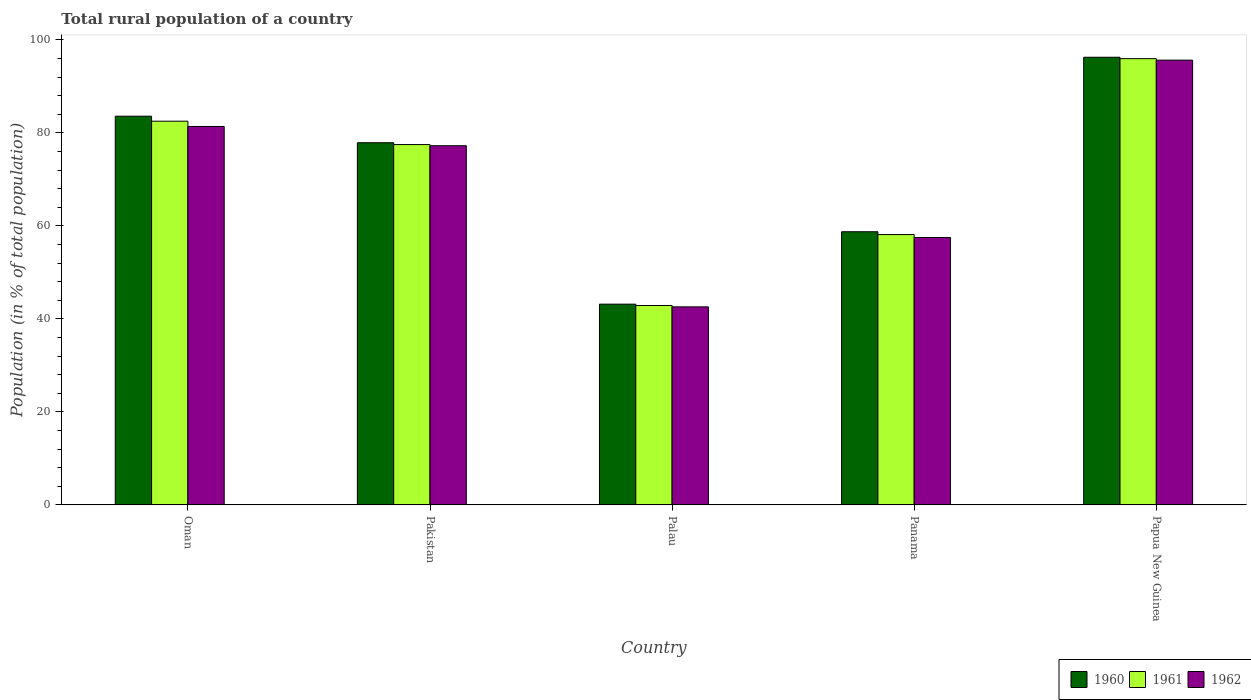How many different coloured bars are there?
Provide a succinct answer. 3. How many groups of bars are there?
Provide a short and direct response. 5. How many bars are there on the 2nd tick from the right?
Keep it short and to the point. 3. What is the label of the 3rd group of bars from the left?
Make the answer very short. Palau. In how many cases, is the number of bars for a given country not equal to the number of legend labels?
Your answer should be very brief. 0. What is the rural population in 1961 in Pakistan?
Make the answer very short. 77.5. Across all countries, what is the maximum rural population in 1961?
Provide a short and direct response. 95.98. Across all countries, what is the minimum rural population in 1962?
Your response must be concise. 42.59. In which country was the rural population in 1962 maximum?
Your response must be concise. Papua New Guinea. In which country was the rural population in 1962 minimum?
Make the answer very short. Palau. What is the total rural population in 1961 in the graph?
Your answer should be very brief. 357.03. What is the difference between the rural population in 1961 in Oman and that in Panama?
Provide a short and direct response. 24.38. What is the difference between the rural population in 1960 in Pakistan and the rural population in 1962 in Panama?
Make the answer very short. 20.39. What is the average rural population in 1961 per country?
Keep it short and to the point. 71.41. What is the difference between the rural population of/in 1960 and rural population of/in 1961 in Palau?
Ensure brevity in your answer.  0.29. In how many countries, is the rural population in 1962 greater than 80 %?
Offer a very short reply. 2. What is the ratio of the rural population in 1960 in Panama to that in Papua New Guinea?
Keep it short and to the point. 0.61. Is the difference between the rural population in 1960 in Pakistan and Palau greater than the difference between the rural population in 1961 in Pakistan and Palau?
Provide a succinct answer. Yes. What is the difference between the highest and the second highest rural population in 1960?
Your response must be concise. 12.68. What is the difference between the highest and the lowest rural population in 1962?
Give a very brief answer. 53.06. In how many countries, is the rural population in 1961 greater than the average rural population in 1961 taken over all countries?
Your response must be concise. 3. Is it the case that in every country, the sum of the rural population in 1961 and rural population in 1962 is greater than the rural population in 1960?
Provide a succinct answer. Yes. Are all the bars in the graph horizontal?
Provide a succinct answer. No. How many countries are there in the graph?
Offer a terse response. 5. What is the difference between two consecutive major ticks on the Y-axis?
Make the answer very short. 20. Does the graph contain any zero values?
Your answer should be very brief. No. How many legend labels are there?
Ensure brevity in your answer.  3. How are the legend labels stacked?
Your answer should be very brief. Horizontal. What is the title of the graph?
Give a very brief answer. Total rural population of a country. What is the label or title of the X-axis?
Keep it short and to the point. Country. What is the label or title of the Y-axis?
Keep it short and to the point. Population (in % of total population). What is the Population (in % of total population) in 1960 in Oman?
Your response must be concise. 83.6. What is the Population (in % of total population) of 1961 in Oman?
Provide a short and direct response. 82.53. What is the Population (in % of total population) of 1962 in Oman?
Your response must be concise. 81.39. What is the Population (in % of total population) in 1960 in Pakistan?
Provide a succinct answer. 77.9. What is the Population (in % of total population) in 1961 in Pakistan?
Provide a short and direct response. 77.5. What is the Population (in % of total population) of 1962 in Pakistan?
Offer a terse response. 77.25. What is the Population (in % of total population) in 1960 in Palau?
Make the answer very short. 43.18. What is the Population (in % of total population) in 1961 in Palau?
Your response must be concise. 42.89. What is the Population (in % of total population) in 1962 in Palau?
Offer a very short reply. 42.59. What is the Population (in % of total population) in 1960 in Panama?
Provide a short and direct response. 58.75. What is the Population (in % of total population) of 1961 in Panama?
Provide a succinct answer. 58.15. What is the Population (in % of total population) in 1962 in Panama?
Your response must be concise. 57.51. What is the Population (in % of total population) in 1960 in Papua New Guinea?
Keep it short and to the point. 96.28. What is the Population (in % of total population) of 1961 in Papua New Guinea?
Make the answer very short. 95.98. What is the Population (in % of total population) in 1962 in Papua New Guinea?
Give a very brief answer. 95.65. Across all countries, what is the maximum Population (in % of total population) in 1960?
Provide a succinct answer. 96.28. Across all countries, what is the maximum Population (in % of total population) of 1961?
Your response must be concise. 95.98. Across all countries, what is the maximum Population (in % of total population) in 1962?
Offer a very short reply. 95.65. Across all countries, what is the minimum Population (in % of total population) of 1960?
Provide a short and direct response. 43.18. Across all countries, what is the minimum Population (in % of total population) of 1961?
Provide a succinct answer. 42.89. Across all countries, what is the minimum Population (in % of total population) in 1962?
Your answer should be compact. 42.59. What is the total Population (in % of total population) in 1960 in the graph?
Give a very brief answer. 359.7. What is the total Population (in % of total population) of 1961 in the graph?
Provide a succinct answer. 357.03. What is the total Population (in % of total population) in 1962 in the graph?
Your response must be concise. 354.4. What is the difference between the Population (in % of total population) of 1960 in Oman and that in Pakistan?
Your response must be concise. 5.7. What is the difference between the Population (in % of total population) of 1961 in Oman and that in Pakistan?
Make the answer very short. 5.03. What is the difference between the Population (in % of total population) in 1962 in Oman and that in Pakistan?
Provide a short and direct response. 4.14. What is the difference between the Population (in % of total population) of 1960 in Oman and that in Palau?
Your answer should be very brief. 40.42. What is the difference between the Population (in % of total population) in 1961 in Oman and that in Palau?
Make the answer very short. 39.64. What is the difference between the Population (in % of total population) of 1962 in Oman and that in Palau?
Offer a very short reply. 38.8. What is the difference between the Population (in % of total population) of 1960 in Oman and that in Panama?
Offer a very short reply. 24.85. What is the difference between the Population (in % of total population) of 1961 in Oman and that in Panama?
Offer a terse response. 24.38. What is the difference between the Population (in % of total population) of 1962 in Oman and that in Panama?
Give a very brief answer. 23.89. What is the difference between the Population (in % of total population) of 1960 in Oman and that in Papua New Guinea?
Provide a succinct answer. -12.68. What is the difference between the Population (in % of total population) of 1961 in Oman and that in Papua New Guinea?
Offer a very short reply. -13.45. What is the difference between the Population (in % of total population) of 1962 in Oman and that in Papua New Guinea?
Provide a short and direct response. -14.26. What is the difference between the Population (in % of total population) of 1960 in Pakistan and that in Palau?
Provide a short and direct response. 34.72. What is the difference between the Population (in % of total population) of 1961 in Pakistan and that in Palau?
Provide a short and direct response. 34.61. What is the difference between the Population (in % of total population) of 1962 in Pakistan and that in Palau?
Provide a succinct answer. 34.65. What is the difference between the Population (in % of total population) of 1960 in Pakistan and that in Panama?
Your answer should be compact. 19.14. What is the difference between the Population (in % of total population) in 1961 in Pakistan and that in Panama?
Your answer should be compact. 19.35. What is the difference between the Population (in % of total population) in 1962 in Pakistan and that in Panama?
Offer a very short reply. 19.74. What is the difference between the Population (in % of total population) in 1960 in Pakistan and that in Papua New Guinea?
Your answer should be very brief. -18.38. What is the difference between the Population (in % of total population) in 1961 in Pakistan and that in Papua New Guinea?
Give a very brief answer. -18.48. What is the difference between the Population (in % of total population) in 1962 in Pakistan and that in Papua New Guinea?
Ensure brevity in your answer.  -18.4. What is the difference between the Population (in % of total population) in 1960 in Palau and that in Panama?
Provide a succinct answer. -15.57. What is the difference between the Population (in % of total population) of 1961 in Palau and that in Panama?
Offer a very short reply. -15.26. What is the difference between the Population (in % of total population) in 1962 in Palau and that in Panama?
Offer a very short reply. -14.91. What is the difference between the Population (in % of total population) of 1960 in Palau and that in Papua New Guinea?
Offer a terse response. -53.1. What is the difference between the Population (in % of total population) in 1961 in Palau and that in Papua New Guinea?
Offer a very short reply. -53.09. What is the difference between the Population (in % of total population) of 1962 in Palau and that in Papua New Guinea?
Ensure brevity in your answer.  -53.06. What is the difference between the Population (in % of total population) of 1960 in Panama and that in Papua New Guinea?
Provide a succinct answer. -37.52. What is the difference between the Population (in % of total population) of 1961 in Panama and that in Papua New Guinea?
Offer a very short reply. -37.83. What is the difference between the Population (in % of total population) of 1962 in Panama and that in Papua New Guinea?
Make the answer very short. -38.15. What is the difference between the Population (in % of total population) of 1960 in Oman and the Population (in % of total population) of 1961 in Pakistan?
Provide a succinct answer. 6.1. What is the difference between the Population (in % of total population) of 1960 in Oman and the Population (in % of total population) of 1962 in Pakistan?
Offer a terse response. 6.35. What is the difference between the Population (in % of total population) of 1961 in Oman and the Population (in % of total population) of 1962 in Pakistan?
Keep it short and to the point. 5.28. What is the difference between the Population (in % of total population) in 1960 in Oman and the Population (in % of total population) in 1961 in Palau?
Ensure brevity in your answer.  40.71. What is the difference between the Population (in % of total population) of 1960 in Oman and the Population (in % of total population) of 1962 in Palau?
Give a very brief answer. 41.01. What is the difference between the Population (in % of total population) in 1961 in Oman and the Population (in % of total population) in 1962 in Palau?
Give a very brief answer. 39.93. What is the difference between the Population (in % of total population) in 1960 in Oman and the Population (in % of total population) in 1961 in Panama?
Offer a terse response. 25.45. What is the difference between the Population (in % of total population) in 1960 in Oman and the Population (in % of total population) in 1962 in Panama?
Offer a very short reply. 26.09. What is the difference between the Population (in % of total population) of 1961 in Oman and the Population (in % of total population) of 1962 in Panama?
Give a very brief answer. 25.02. What is the difference between the Population (in % of total population) in 1960 in Oman and the Population (in % of total population) in 1961 in Papua New Guinea?
Your answer should be very brief. -12.38. What is the difference between the Population (in % of total population) in 1960 in Oman and the Population (in % of total population) in 1962 in Papua New Guinea?
Give a very brief answer. -12.05. What is the difference between the Population (in % of total population) in 1961 in Oman and the Population (in % of total population) in 1962 in Papua New Guinea?
Ensure brevity in your answer.  -13.13. What is the difference between the Population (in % of total population) of 1960 in Pakistan and the Population (in % of total population) of 1961 in Palau?
Make the answer very short. 35.01. What is the difference between the Population (in % of total population) in 1960 in Pakistan and the Population (in % of total population) in 1962 in Palau?
Keep it short and to the point. 35.3. What is the difference between the Population (in % of total population) of 1961 in Pakistan and the Population (in % of total population) of 1962 in Palau?
Your response must be concise. 34.9. What is the difference between the Population (in % of total population) in 1960 in Pakistan and the Population (in % of total population) in 1961 in Panama?
Your answer should be very brief. 19.75. What is the difference between the Population (in % of total population) of 1960 in Pakistan and the Population (in % of total population) of 1962 in Panama?
Your response must be concise. 20.39. What is the difference between the Population (in % of total population) of 1961 in Pakistan and the Population (in % of total population) of 1962 in Panama?
Make the answer very short. 19.99. What is the difference between the Population (in % of total population) in 1960 in Pakistan and the Population (in % of total population) in 1961 in Papua New Guinea?
Offer a terse response. -18.08. What is the difference between the Population (in % of total population) in 1960 in Pakistan and the Population (in % of total population) in 1962 in Papua New Guinea?
Give a very brief answer. -17.76. What is the difference between the Population (in % of total population) in 1961 in Pakistan and the Population (in % of total population) in 1962 in Papua New Guinea?
Provide a short and direct response. -18.15. What is the difference between the Population (in % of total population) of 1960 in Palau and the Population (in % of total population) of 1961 in Panama?
Your response must be concise. -14.97. What is the difference between the Population (in % of total population) in 1960 in Palau and the Population (in % of total population) in 1962 in Panama?
Your answer should be very brief. -14.33. What is the difference between the Population (in % of total population) in 1961 in Palau and the Population (in % of total population) in 1962 in Panama?
Offer a very short reply. -14.62. What is the difference between the Population (in % of total population) of 1960 in Palau and the Population (in % of total population) of 1961 in Papua New Guinea?
Your answer should be compact. -52.8. What is the difference between the Population (in % of total population) of 1960 in Palau and the Population (in % of total population) of 1962 in Papua New Guinea?
Your answer should be compact. -52.48. What is the difference between the Population (in % of total population) of 1961 in Palau and the Population (in % of total population) of 1962 in Papua New Guinea?
Your answer should be very brief. -52.77. What is the difference between the Population (in % of total population) of 1960 in Panama and the Population (in % of total population) of 1961 in Papua New Guinea?
Offer a very short reply. -37.23. What is the difference between the Population (in % of total population) of 1960 in Panama and the Population (in % of total population) of 1962 in Papua New Guinea?
Ensure brevity in your answer.  -36.9. What is the difference between the Population (in % of total population) in 1961 in Panama and the Population (in % of total population) in 1962 in Papua New Guinea?
Provide a succinct answer. -37.51. What is the average Population (in % of total population) in 1960 per country?
Make the answer very short. 71.94. What is the average Population (in % of total population) in 1961 per country?
Provide a succinct answer. 71.41. What is the average Population (in % of total population) in 1962 per country?
Offer a very short reply. 70.88. What is the difference between the Population (in % of total population) of 1960 and Population (in % of total population) of 1961 in Oman?
Give a very brief answer. 1.07. What is the difference between the Population (in % of total population) of 1960 and Population (in % of total population) of 1962 in Oman?
Provide a succinct answer. 2.21. What is the difference between the Population (in % of total population) of 1961 and Population (in % of total population) of 1962 in Oman?
Make the answer very short. 1.13. What is the difference between the Population (in % of total population) of 1960 and Population (in % of total population) of 1961 in Pakistan?
Make the answer very short. 0.4. What is the difference between the Population (in % of total population) in 1960 and Population (in % of total population) in 1962 in Pakistan?
Keep it short and to the point. 0.65. What is the difference between the Population (in % of total population) of 1961 and Population (in % of total population) of 1962 in Pakistan?
Provide a succinct answer. 0.25. What is the difference between the Population (in % of total population) of 1960 and Population (in % of total population) of 1961 in Palau?
Provide a short and direct response. 0.29. What is the difference between the Population (in % of total population) of 1960 and Population (in % of total population) of 1962 in Palau?
Your answer should be very brief. 0.58. What is the difference between the Population (in % of total population) of 1961 and Population (in % of total population) of 1962 in Palau?
Keep it short and to the point. 0.29. What is the difference between the Population (in % of total population) of 1960 and Population (in % of total population) of 1961 in Panama?
Make the answer very short. 0.6. What is the difference between the Population (in % of total population) of 1960 and Population (in % of total population) of 1962 in Panama?
Your response must be concise. 1.25. What is the difference between the Population (in % of total population) in 1961 and Population (in % of total population) in 1962 in Panama?
Your response must be concise. 0.64. What is the difference between the Population (in % of total population) of 1960 and Population (in % of total population) of 1961 in Papua New Guinea?
Give a very brief answer. 0.3. What is the difference between the Population (in % of total population) in 1960 and Population (in % of total population) in 1962 in Papua New Guinea?
Give a very brief answer. 0.62. What is the difference between the Population (in % of total population) of 1961 and Population (in % of total population) of 1962 in Papua New Guinea?
Offer a terse response. 0.32. What is the ratio of the Population (in % of total population) of 1960 in Oman to that in Pakistan?
Your response must be concise. 1.07. What is the ratio of the Population (in % of total population) in 1961 in Oman to that in Pakistan?
Make the answer very short. 1.06. What is the ratio of the Population (in % of total population) in 1962 in Oman to that in Pakistan?
Your response must be concise. 1.05. What is the ratio of the Population (in % of total population) of 1960 in Oman to that in Palau?
Provide a succinct answer. 1.94. What is the ratio of the Population (in % of total population) of 1961 in Oman to that in Palau?
Your answer should be compact. 1.92. What is the ratio of the Population (in % of total population) in 1962 in Oman to that in Palau?
Make the answer very short. 1.91. What is the ratio of the Population (in % of total population) in 1960 in Oman to that in Panama?
Your answer should be very brief. 1.42. What is the ratio of the Population (in % of total population) of 1961 in Oman to that in Panama?
Your answer should be compact. 1.42. What is the ratio of the Population (in % of total population) of 1962 in Oman to that in Panama?
Ensure brevity in your answer.  1.42. What is the ratio of the Population (in % of total population) of 1960 in Oman to that in Papua New Guinea?
Provide a succinct answer. 0.87. What is the ratio of the Population (in % of total population) of 1961 in Oman to that in Papua New Guinea?
Your response must be concise. 0.86. What is the ratio of the Population (in % of total population) of 1962 in Oman to that in Papua New Guinea?
Offer a very short reply. 0.85. What is the ratio of the Population (in % of total population) in 1960 in Pakistan to that in Palau?
Offer a very short reply. 1.8. What is the ratio of the Population (in % of total population) of 1961 in Pakistan to that in Palau?
Keep it short and to the point. 1.81. What is the ratio of the Population (in % of total population) of 1962 in Pakistan to that in Palau?
Offer a very short reply. 1.81. What is the ratio of the Population (in % of total population) in 1960 in Pakistan to that in Panama?
Offer a terse response. 1.33. What is the ratio of the Population (in % of total population) of 1961 in Pakistan to that in Panama?
Offer a very short reply. 1.33. What is the ratio of the Population (in % of total population) in 1962 in Pakistan to that in Panama?
Your answer should be very brief. 1.34. What is the ratio of the Population (in % of total population) of 1960 in Pakistan to that in Papua New Guinea?
Keep it short and to the point. 0.81. What is the ratio of the Population (in % of total population) in 1961 in Pakistan to that in Papua New Guinea?
Give a very brief answer. 0.81. What is the ratio of the Population (in % of total population) in 1962 in Pakistan to that in Papua New Guinea?
Offer a terse response. 0.81. What is the ratio of the Population (in % of total population) in 1960 in Palau to that in Panama?
Your response must be concise. 0.73. What is the ratio of the Population (in % of total population) of 1961 in Palau to that in Panama?
Make the answer very short. 0.74. What is the ratio of the Population (in % of total population) of 1962 in Palau to that in Panama?
Provide a short and direct response. 0.74. What is the ratio of the Population (in % of total population) in 1960 in Palau to that in Papua New Guinea?
Your response must be concise. 0.45. What is the ratio of the Population (in % of total population) in 1961 in Palau to that in Papua New Guinea?
Provide a succinct answer. 0.45. What is the ratio of the Population (in % of total population) of 1962 in Palau to that in Papua New Guinea?
Provide a succinct answer. 0.45. What is the ratio of the Population (in % of total population) of 1960 in Panama to that in Papua New Guinea?
Make the answer very short. 0.61. What is the ratio of the Population (in % of total population) of 1961 in Panama to that in Papua New Guinea?
Offer a very short reply. 0.61. What is the ratio of the Population (in % of total population) of 1962 in Panama to that in Papua New Guinea?
Offer a terse response. 0.6. What is the difference between the highest and the second highest Population (in % of total population) in 1960?
Your answer should be very brief. 12.68. What is the difference between the highest and the second highest Population (in % of total population) in 1961?
Provide a short and direct response. 13.45. What is the difference between the highest and the second highest Population (in % of total population) of 1962?
Provide a short and direct response. 14.26. What is the difference between the highest and the lowest Population (in % of total population) of 1960?
Keep it short and to the point. 53.1. What is the difference between the highest and the lowest Population (in % of total population) of 1961?
Make the answer very short. 53.09. What is the difference between the highest and the lowest Population (in % of total population) of 1962?
Keep it short and to the point. 53.06. 